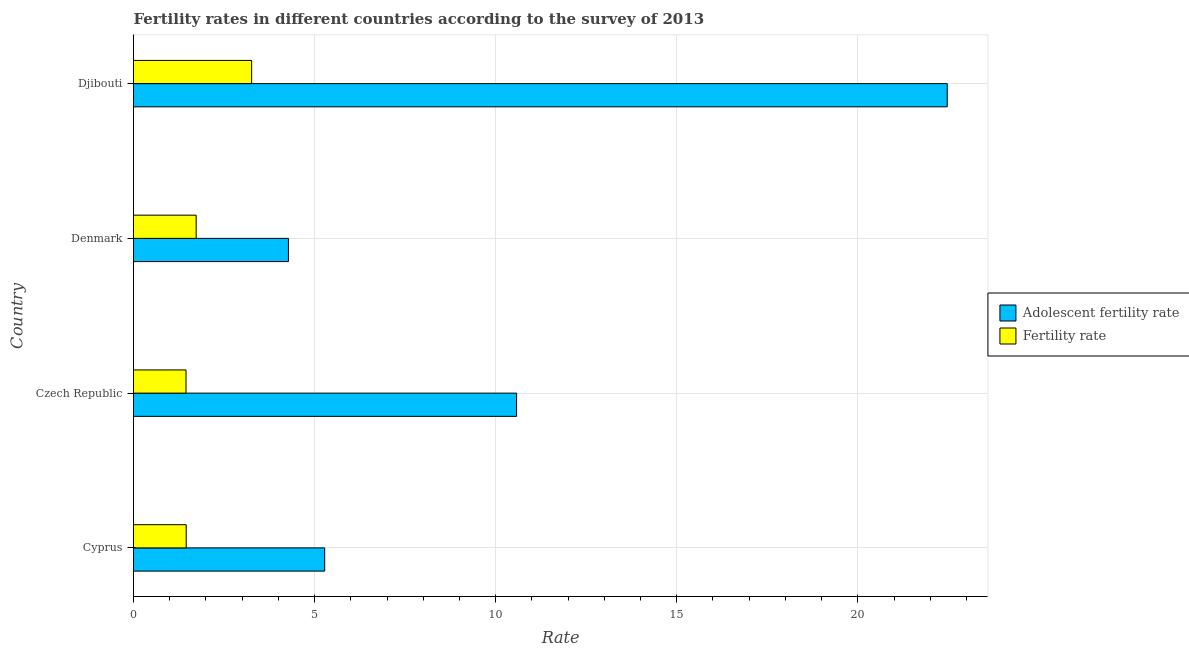How many different coloured bars are there?
Provide a short and direct response. 2. How many groups of bars are there?
Offer a very short reply. 4. How many bars are there on the 2nd tick from the bottom?
Your answer should be very brief. 2. What is the label of the 4th group of bars from the top?
Make the answer very short. Cyprus. What is the adolescent fertility rate in Cyprus?
Make the answer very short. 5.28. Across all countries, what is the maximum fertility rate?
Provide a short and direct response. 3.26. Across all countries, what is the minimum fertility rate?
Make the answer very short. 1.45. In which country was the fertility rate maximum?
Offer a terse response. Djibouti. In which country was the fertility rate minimum?
Provide a short and direct response. Czech Republic. What is the total fertility rate in the graph?
Provide a succinct answer. 7.9. What is the difference between the adolescent fertility rate in Denmark and that in Djibouti?
Your response must be concise. -18.19. What is the difference between the adolescent fertility rate in Czech Republic and the fertility rate in Djibouti?
Offer a terse response. 7.32. What is the average adolescent fertility rate per country?
Keep it short and to the point. 10.65. What is the difference between the fertility rate and adolescent fertility rate in Djibouti?
Offer a very short reply. -19.21. What is the ratio of the adolescent fertility rate in Cyprus to that in Czech Republic?
Your answer should be compact. 0.5. Is the difference between the fertility rate in Czech Republic and Denmark greater than the difference between the adolescent fertility rate in Czech Republic and Denmark?
Give a very brief answer. No. What is the difference between the highest and the second highest adolescent fertility rate?
Offer a terse response. 11.89. What is the difference between the highest and the lowest adolescent fertility rate?
Make the answer very short. 18.19. What does the 2nd bar from the top in Cyprus represents?
Make the answer very short. Adolescent fertility rate. What does the 2nd bar from the bottom in Denmark represents?
Provide a short and direct response. Fertility rate. How many countries are there in the graph?
Make the answer very short. 4. What is the difference between two consecutive major ticks on the X-axis?
Give a very brief answer. 5. Are the values on the major ticks of X-axis written in scientific E-notation?
Offer a terse response. No. Does the graph contain any zero values?
Your answer should be very brief. No. Does the graph contain grids?
Offer a very short reply. Yes. How are the legend labels stacked?
Give a very brief answer. Vertical. What is the title of the graph?
Keep it short and to the point. Fertility rates in different countries according to the survey of 2013. What is the label or title of the X-axis?
Offer a very short reply. Rate. What is the label or title of the Y-axis?
Provide a succinct answer. Country. What is the Rate of Adolescent fertility rate in Cyprus?
Give a very brief answer. 5.28. What is the Rate in Fertility rate in Cyprus?
Ensure brevity in your answer.  1.46. What is the Rate of Adolescent fertility rate in Czech Republic?
Give a very brief answer. 10.58. What is the Rate of Fertility rate in Czech Republic?
Keep it short and to the point. 1.45. What is the Rate in Adolescent fertility rate in Denmark?
Your answer should be very brief. 4.28. What is the Rate of Fertility rate in Denmark?
Offer a terse response. 1.73. What is the Rate of Adolescent fertility rate in Djibouti?
Your answer should be very brief. 22.47. What is the Rate in Fertility rate in Djibouti?
Keep it short and to the point. 3.26. Across all countries, what is the maximum Rate in Adolescent fertility rate?
Your answer should be compact. 22.47. Across all countries, what is the maximum Rate of Fertility rate?
Your answer should be compact. 3.26. Across all countries, what is the minimum Rate in Adolescent fertility rate?
Your response must be concise. 4.28. Across all countries, what is the minimum Rate in Fertility rate?
Keep it short and to the point. 1.45. What is the total Rate in Adolescent fertility rate in the graph?
Give a very brief answer. 42.6. What is the total Rate in Fertility rate in the graph?
Offer a very short reply. 7.9. What is the difference between the Rate in Adolescent fertility rate in Cyprus and that in Czech Republic?
Give a very brief answer. -5.3. What is the difference between the Rate of Fertility rate in Cyprus and that in Czech Republic?
Offer a very short reply. 0.01. What is the difference between the Rate of Adolescent fertility rate in Cyprus and that in Denmark?
Your answer should be compact. 1. What is the difference between the Rate of Fertility rate in Cyprus and that in Denmark?
Offer a terse response. -0.28. What is the difference between the Rate of Adolescent fertility rate in Cyprus and that in Djibouti?
Provide a short and direct response. -17.19. What is the difference between the Rate in Fertility rate in Cyprus and that in Djibouti?
Your answer should be very brief. -1.81. What is the difference between the Rate in Adolescent fertility rate in Czech Republic and that in Denmark?
Offer a terse response. 6.3. What is the difference between the Rate in Fertility rate in Czech Republic and that in Denmark?
Your response must be concise. -0.28. What is the difference between the Rate of Adolescent fertility rate in Czech Republic and that in Djibouti?
Make the answer very short. -11.89. What is the difference between the Rate in Fertility rate in Czech Republic and that in Djibouti?
Your response must be concise. -1.81. What is the difference between the Rate of Adolescent fertility rate in Denmark and that in Djibouti?
Make the answer very short. -18.19. What is the difference between the Rate in Fertility rate in Denmark and that in Djibouti?
Give a very brief answer. -1.53. What is the difference between the Rate in Adolescent fertility rate in Cyprus and the Rate in Fertility rate in Czech Republic?
Give a very brief answer. 3.83. What is the difference between the Rate in Adolescent fertility rate in Cyprus and the Rate in Fertility rate in Denmark?
Your answer should be compact. 3.55. What is the difference between the Rate of Adolescent fertility rate in Cyprus and the Rate of Fertility rate in Djibouti?
Make the answer very short. 2.02. What is the difference between the Rate of Adolescent fertility rate in Czech Republic and the Rate of Fertility rate in Denmark?
Offer a terse response. 8.85. What is the difference between the Rate of Adolescent fertility rate in Czech Republic and the Rate of Fertility rate in Djibouti?
Your answer should be compact. 7.32. What is the difference between the Rate of Adolescent fertility rate in Denmark and the Rate of Fertility rate in Djibouti?
Provide a succinct answer. 1.02. What is the average Rate in Adolescent fertility rate per country?
Ensure brevity in your answer.  10.65. What is the average Rate in Fertility rate per country?
Give a very brief answer. 1.97. What is the difference between the Rate of Adolescent fertility rate and Rate of Fertility rate in Cyprus?
Give a very brief answer. 3.82. What is the difference between the Rate of Adolescent fertility rate and Rate of Fertility rate in Czech Republic?
Keep it short and to the point. 9.13. What is the difference between the Rate of Adolescent fertility rate and Rate of Fertility rate in Denmark?
Your answer should be very brief. 2.55. What is the difference between the Rate of Adolescent fertility rate and Rate of Fertility rate in Djibouti?
Your answer should be very brief. 19.21. What is the ratio of the Rate of Adolescent fertility rate in Cyprus to that in Czech Republic?
Offer a very short reply. 0.5. What is the ratio of the Rate in Adolescent fertility rate in Cyprus to that in Denmark?
Give a very brief answer. 1.23. What is the ratio of the Rate in Fertility rate in Cyprus to that in Denmark?
Offer a very short reply. 0.84. What is the ratio of the Rate in Adolescent fertility rate in Cyprus to that in Djibouti?
Provide a succinct answer. 0.23. What is the ratio of the Rate in Fertility rate in Cyprus to that in Djibouti?
Your answer should be very brief. 0.45. What is the ratio of the Rate in Adolescent fertility rate in Czech Republic to that in Denmark?
Offer a very short reply. 2.47. What is the ratio of the Rate of Fertility rate in Czech Republic to that in Denmark?
Your response must be concise. 0.84. What is the ratio of the Rate of Adolescent fertility rate in Czech Republic to that in Djibouti?
Your answer should be very brief. 0.47. What is the ratio of the Rate in Fertility rate in Czech Republic to that in Djibouti?
Provide a short and direct response. 0.44. What is the ratio of the Rate of Adolescent fertility rate in Denmark to that in Djibouti?
Offer a terse response. 0.19. What is the ratio of the Rate of Fertility rate in Denmark to that in Djibouti?
Offer a terse response. 0.53. What is the difference between the highest and the second highest Rate of Adolescent fertility rate?
Make the answer very short. 11.89. What is the difference between the highest and the second highest Rate in Fertility rate?
Give a very brief answer. 1.53. What is the difference between the highest and the lowest Rate in Adolescent fertility rate?
Offer a very short reply. 18.19. What is the difference between the highest and the lowest Rate in Fertility rate?
Provide a succinct answer. 1.81. 